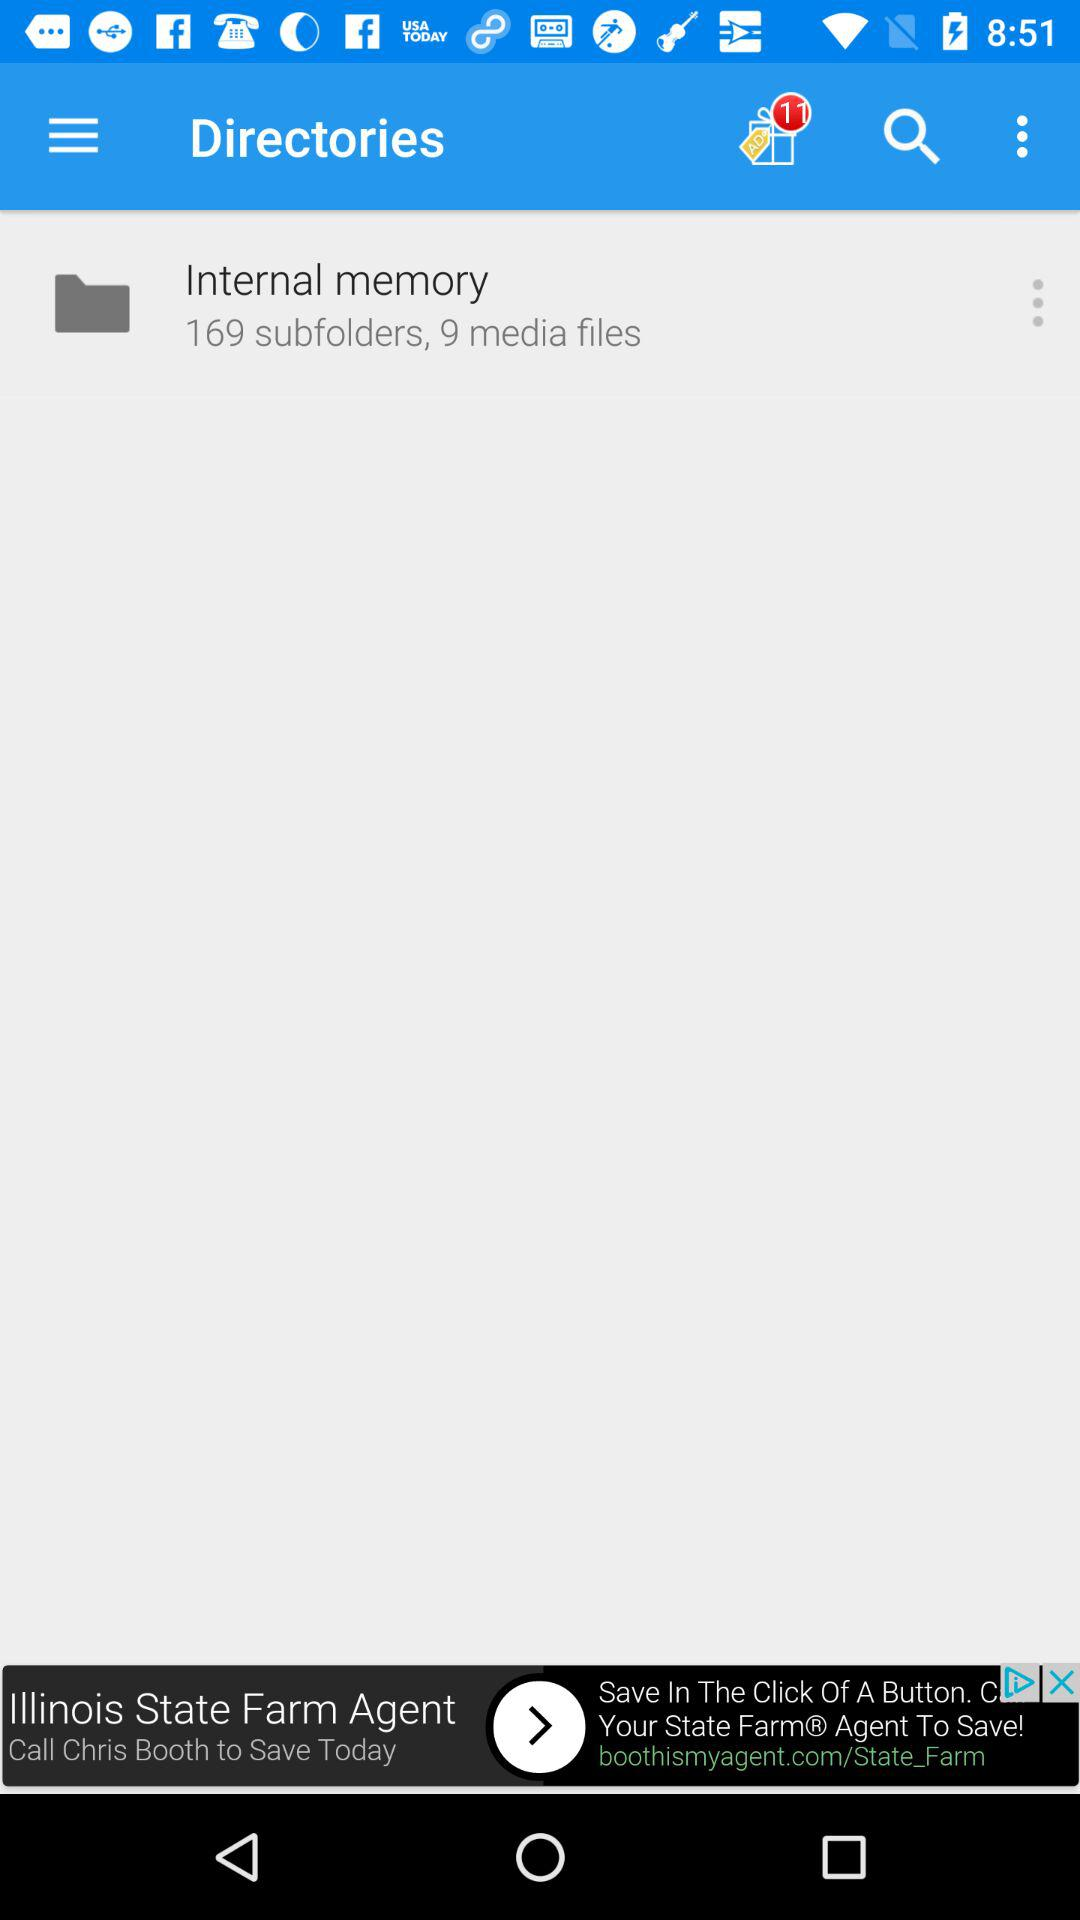How many subfolders are in the "Internal memory"? There are 169 subfolders in the "Internal memory". 